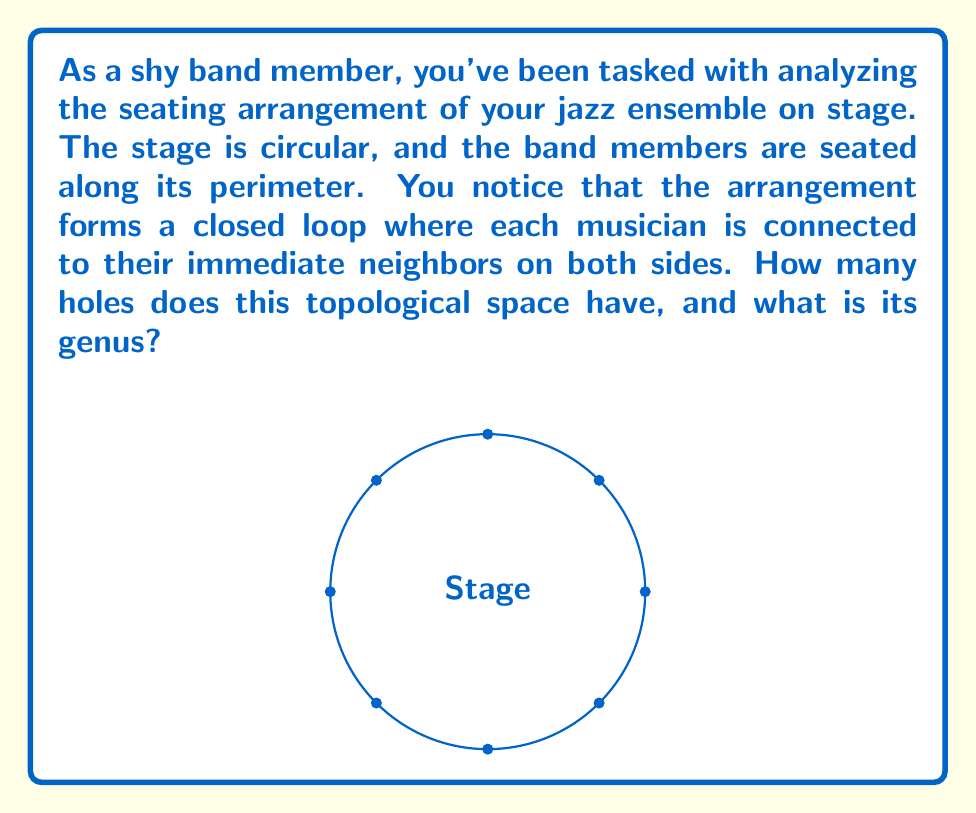Show me your answer to this math problem. Let's approach this step-by-step:

1) First, we need to understand what this arrangement represents topologically:
   - The musicians form a closed loop around the circular stage.
   - Each musician is connected to their immediate neighbors on both sides.

2) This arrangement is topologically equivalent to a circle, or a 1-dimensional sphere, denoted as $S^1$.

3) To determine the number of holes:
   - A circle encloses a single region (the interior of the circle).
   - This interior region is distinct from the exterior.
   - Therefore, the circle has one hole.

4) The genus of a surface is the maximum number of cuts along non-intersecting closed simple curves without disconnecting the surface.
   - For a circle, any cut would disconnect it.
   - Thus, the genus of a circle is 0.

5) We can also confirm this using the Euler characteristic $\chi$:
   - For a circle, $\chi = V - E + F = 0 - 0 + 1 = 1$
   - The relation between Euler characteristic and genus $g$ for a closed surface is:
     $\chi = 2 - 2g$
   - Solving for $g$: $1 = 2 - 2g$ $\Rightarrow$ $g = \frac{2-1}{2} = \frac{1}{2} = 0$

Therefore, the topological space has 1 hole and a genus of 0.
Answer: 1 hole, genus 0 